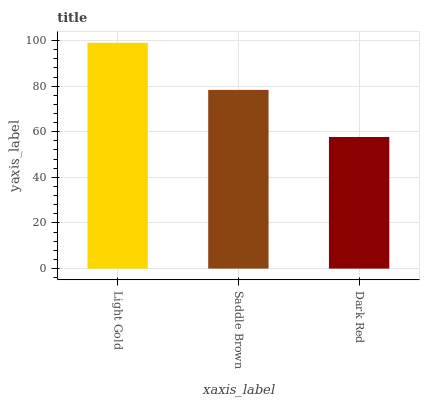Is Dark Red the minimum?
Answer yes or no. Yes. Is Light Gold the maximum?
Answer yes or no. Yes. Is Saddle Brown the minimum?
Answer yes or no. No. Is Saddle Brown the maximum?
Answer yes or no. No. Is Light Gold greater than Saddle Brown?
Answer yes or no. Yes. Is Saddle Brown less than Light Gold?
Answer yes or no. Yes. Is Saddle Brown greater than Light Gold?
Answer yes or no. No. Is Light Gold less than Saddle Brown?
Answer yes or no. No. Is Saddle Brown the high median?
Answer yes or no. Yes. Is Saddle Brown the low median?
Answer yes or no. Yes. Is Light Gold the high median?
Answer yes or no. No. Is Light Gold the low median?
Answer yes or no. No. 